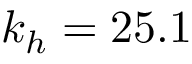<formula> <loc_0><loc_0><loc_500><loc_500>k _ { h } = 2 5 . 1</formula> 